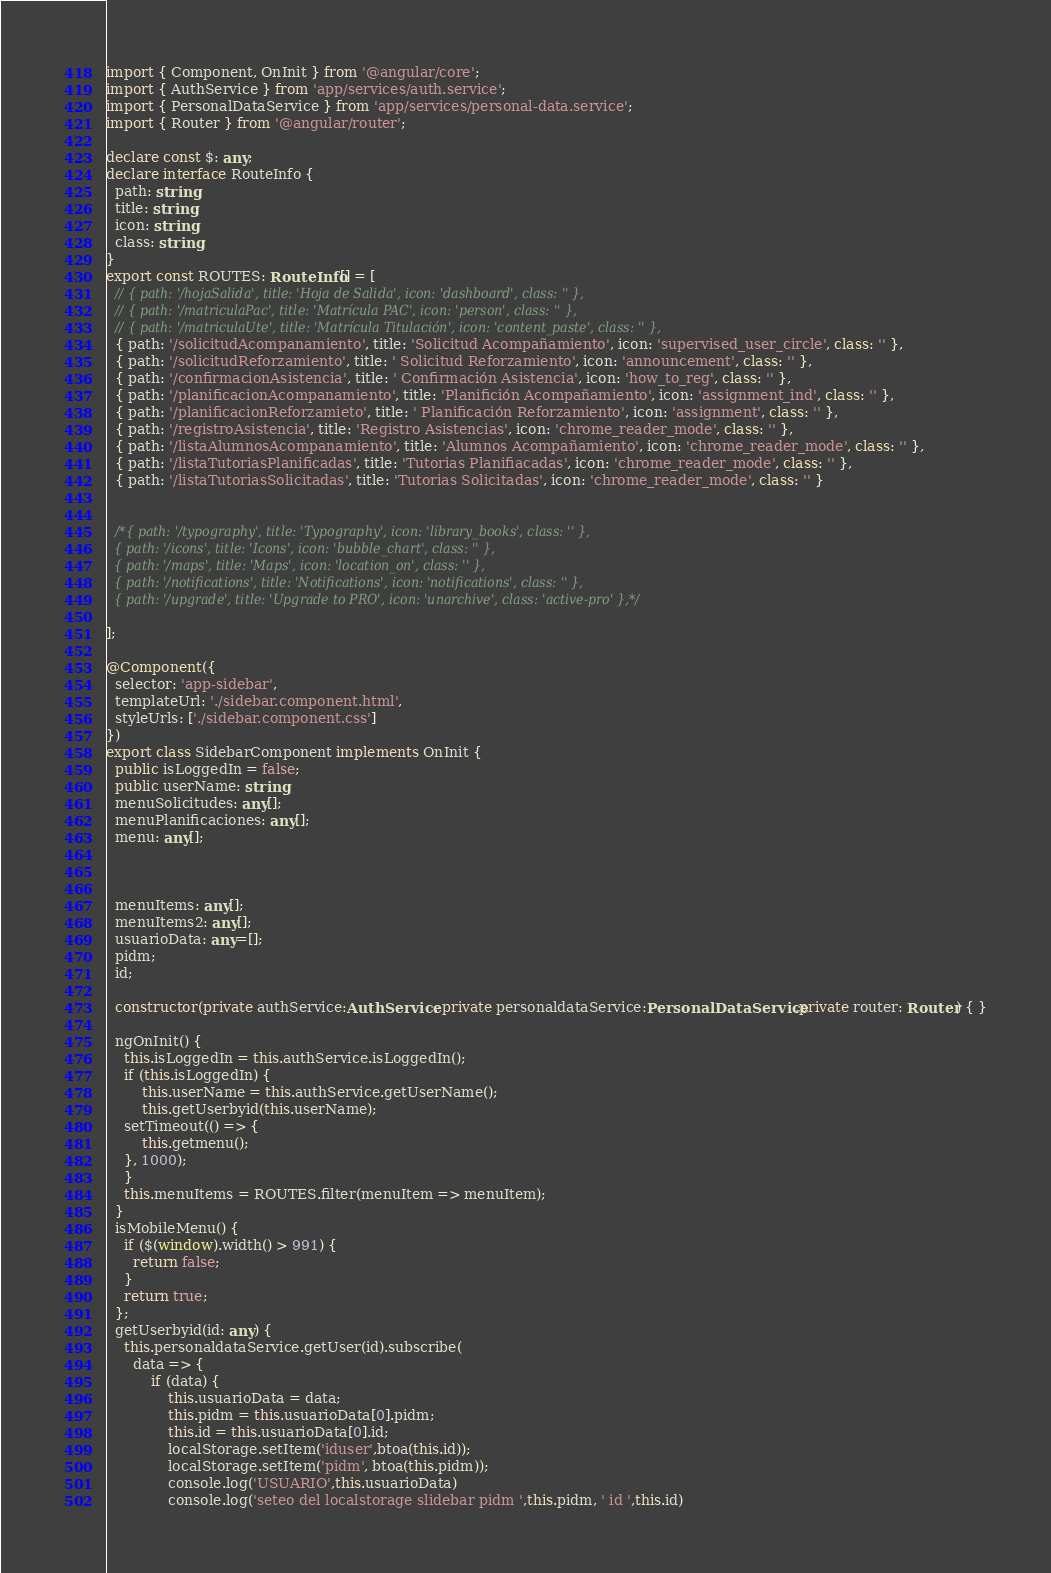<code> <loc_0><loc_0><loc_500><loc_500><_TypeScript_>import { Component, OnInit } from '@angular/core';
import { AuthService } from 'app/services/auth.service';
import { PersonalDataService } from 'app/services/personal-data.service';
import { Router } from '@angular/router';

declare const $: any;
declare interface RouteInfo {
  path: string;
  title: string;
  icon: string;
  class: string;
}
export const ROUTES: RouteInfo[] = [
  // { path: '/hojaSalida', title: 'Hoja de Salida', icon: 'dashboard', class: '' },
  // { path: '/matriculaPac', title: 'Matrícula PAC', icon: 'person', class: '' },
  // { path: '/matriculaUte', title: 'Matrícula Titulación', icon: 'content_paste', class: '' },
  { path: '/solicitudAcompanamiento', title: 'Solicitud Acompañamiento', icon: 'supervised_user_circle', class: '' },
  { path: '/solicitudReforzamiento', title: ' Solicitud Reforzamiento', icon: 'announcement', class: '' },
  { path: '/confirmacionAsistencia', title: ' Confirmación Asistencia', icon: 'how_to_reg', class: '' },
  { path: '/planificacionAcompanamiento', title: 'Planifición Acompañamiento', icon: 'assignment_ind', class: '' },
  { path: '/planificacionReforzamieto', title: ' Planificación Reforzamiento', icon: 'assignment', class: '' },
  { path: '/registroAsistencia', title: 'Registro Asistencias', icon: 'chrome_reader_mode', class: '' },
  { path: '/listaAlumnosAcompanamiento', title: 'Alumnos Acompañamiento', icon: 'chrome_reader_mode', class: '' },
  { path: '/listaTutoriasPlanificadas', title: 'Tutorias Planifiacadas', icon: 'chrome_reader_mode', class: '' },
  { path: '/listaTutoriasSolicitadas', title: 'Tutorias Solicitadas', icon: 'chrome_reader_mode', class: '' }


  /*{ path: '/typography', title: 'Typography', icon: 'library_books', class: '' },
  { path: '/icons', title: 'Icons', icon: 'bubble_chart', class: '' },
  { path: '/maps', title: 'Maps', icon: 'location_on', class: '' },
  { path: '/notifications', title: 'Notifications', icon: 'notifications', class: '' },
  { path: '/upgrade', title: 'Upgrade to PRO', icon: 'unarchive', class: 'active-pro' },*/

];

@Component({
  selector: 'app-sidebar',
  templateUrl: './sidebar.component.html',
  styleUrls: ['./sidebar.component.css']
})
export class SidebarComponent implements OnInit {
  public isLoggedIn = false;
  public userName: string;
  menuSolicitudes: any[];
  menuPlanificaciones: any[];
  menu: any[];



  menuItems: any[];
  menuItems2: any[];
  usuarioData: any=[];
  pidm;
  id;

  constructor(private authService:AuthService, private personaldataService:PersonalDataService,private router: Router) { }

  ngOnInit() {
    this.isLoggedIn = this.authService.isLoggedIn();
    if (this.isLoggedIn) {
        this.userName = this.authService.getUserName();
        this.getUserbyid(this.userName);
    setTimeout(() => {
        this.getmenu();
    }, 1000);
    }
    this.menuItems = ROUTES.filter(menuItem => menuItem);
  }
  isMobileMenu() {
    if ($(window).width() > 991) {
      return false;
    }
    return true;
  };
  getUserbyid(id: any) {
    this.personaldataService.getUser(id).subscribe(
      data => {
          if (data) {
              this.usuarioData = data;
              this.pidm = this.usuarioData[0].pidm;
              this.id = this.usuarioData[0].id;
              localStorage.setItem('iduser',btoa(this.id));
              localStorage.setItem('pidm', btoa(this.pidm));
              console.log('USUARIO',this.usuarioData)
              console.log('seteo del localstorage slidebar pidm ',this.pidm, ' id ',this.id)
</code> 